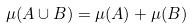<formula> <loc_0><loc_0><loc_500><loc_500>\mu ( A \cup B ) = \mu ( A ) + \mu ( B )</formula> 